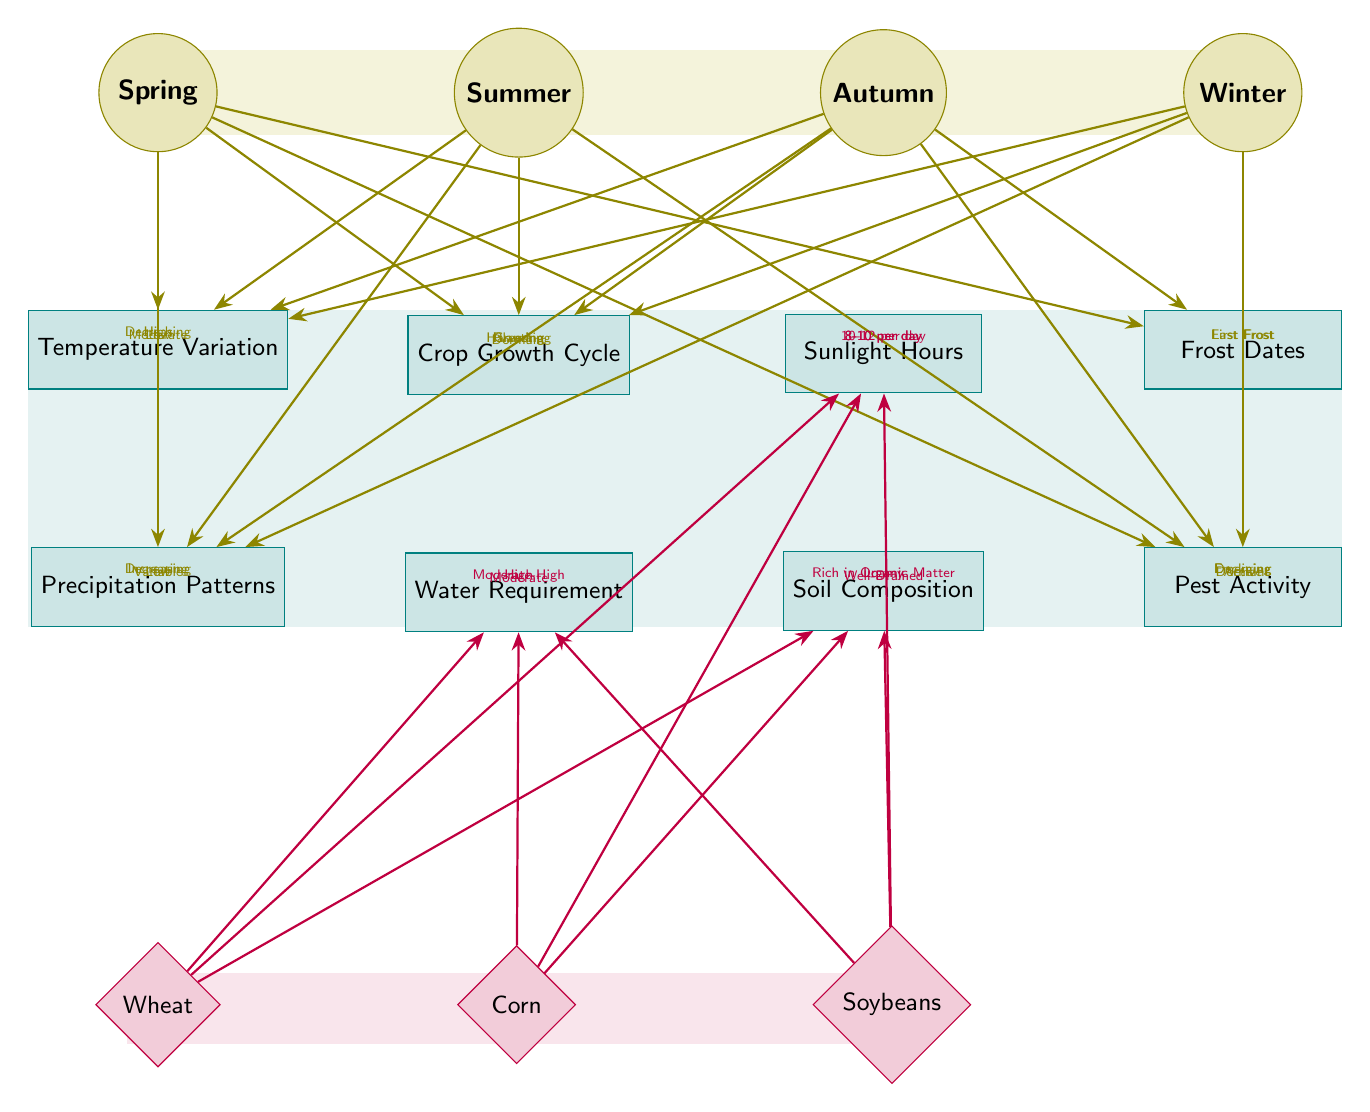What's the temperature variation in winter? The diagram shows that the temperature variation for winter is labeled as "Low," which is indicated by the arrow from winter to temperature.
Answer: Low What is the crop growth cycle phase in summer? In the diagram, the crop growth cycle during summer is represented as "Growing," derived from the connection between summer and crop growth cycle.
Answer: Growing How many seasons are depicted in the diagram? There are four seasons shown in the diagram: Spring, Summer, Autumn, and Winter. This is easily counted by observing the 'season' nodes.
Answer: 4 What does autumn's precipitation pattern indicate? The diagram indicates that autumn's precipitation pattern is "Decreasing," which is marked by the arrow from autumn to precipitation.
Answer: Decreasing Which crop requires high water? The diagram shows that corn requires "High" water, as indicated by the arrow connecting corn to water.
Answer: High What is the frost date change from spring to autumn? According to the diagram, the last frost occurs in spring and the first frost is noted in autumn, indicating a transition of frost dates from spring to autumn.
Answer: Last Frost, First Frost How is sunlight categorized for corn? The diagram specifies that corn requires "10-12 per day" sunlight hours, shown by the connection between corn and sunlight hours.
Answer: 10-12 per day What soil type is required for soybeans? The diagram states that soybeans require soil "Rich in Organic Matter," indicated by the arrow connecting soybeans to soil composition.
Answer: Rich in Organic Matter What is the pest activity in autumn? In the autumn section of the diagram, pest activity is described as "Declining," which is shown by the connection from autumn to pest activity.
Answer: Declining 